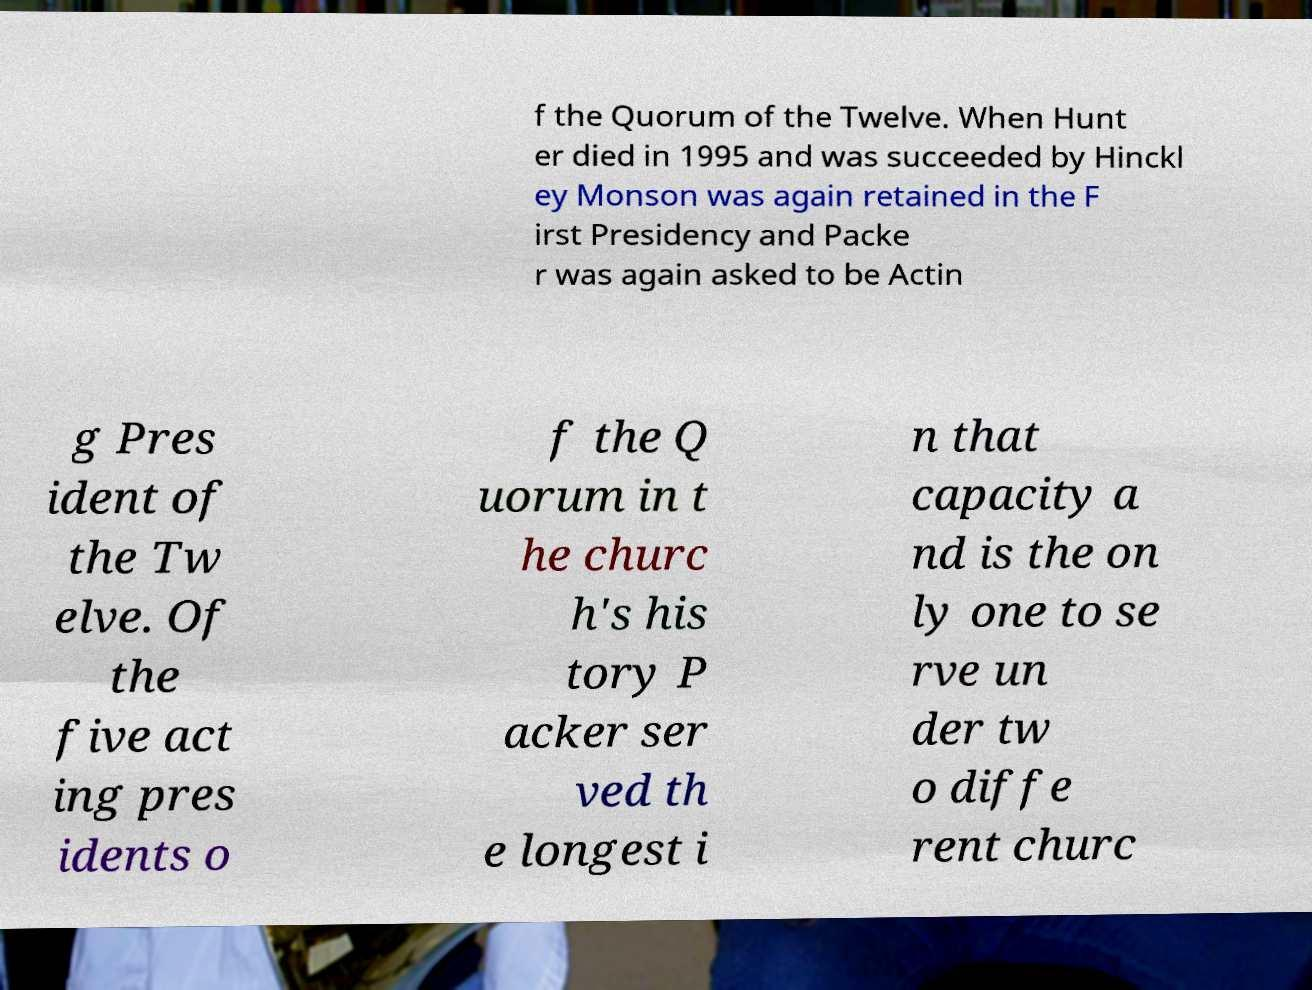Could you extract and type out the text from this image? f the Quorum of the Twelve. When Hunt er died in 1995 and was succeeded by Hinckl ey Monson was again retained in the F irst Presidency and Packe r was again asked to be Actin g Pres ident of the Tw elve. Of the five act ing pres idents o f the Q uorum in t he churc h's his tory P acker ser ved th e longest i n that capacity a nd is the on ly one to se rve un der tw o diffe rent churc 